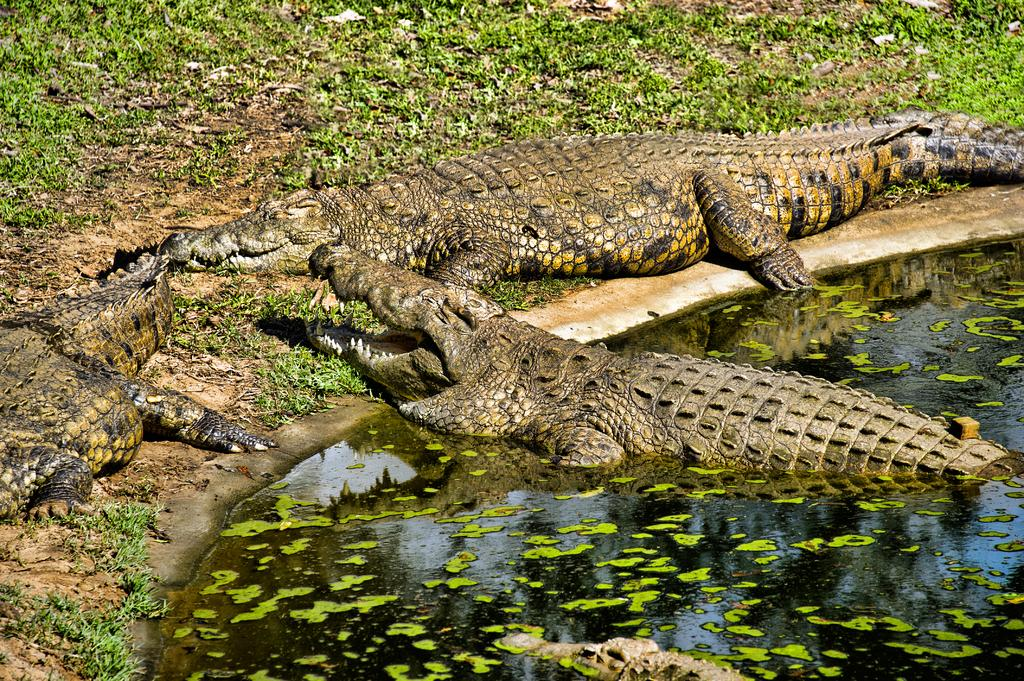How many crocodiles are in the image? There are four crocodiles in the image. Where are the crocodiles located in relation to the water? Two crocodiles are partially in the water, while the other two are on the ground. What type of vegetation can be seen on the ground? Grass is visible on the ground. What type of fruit is being used as a fact in the image? There is no fruit or fact present in the image; it features four crocodiles and grass on the ground. 